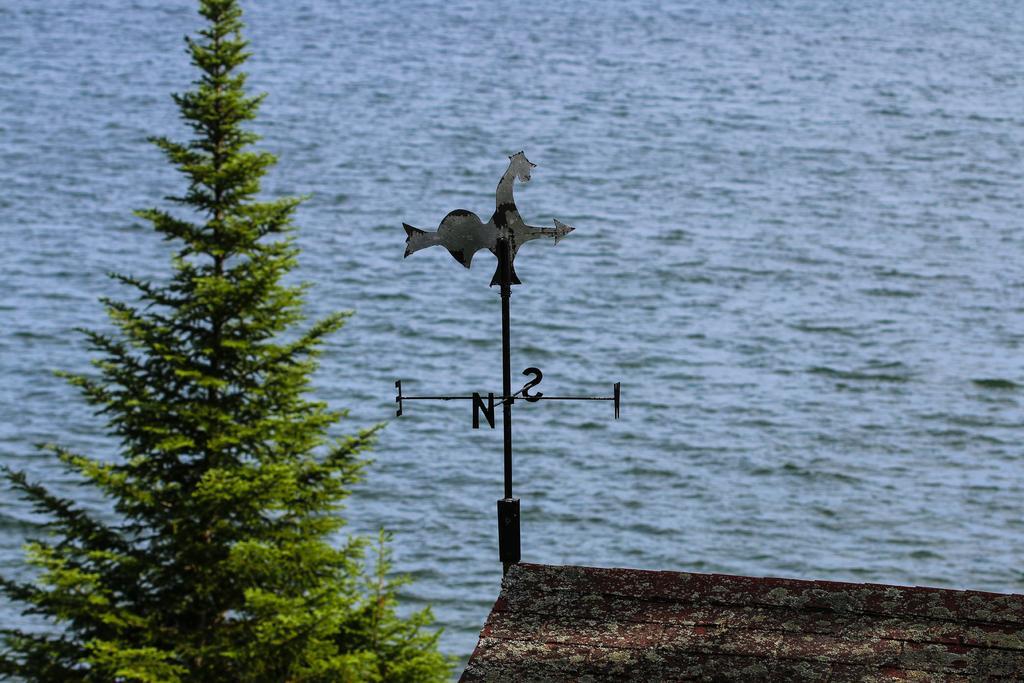Please provide a concise description of this image. In the center of the image we can see a wind vane. On the left side of the image we can see a tree. At the bottom of the image we can see the wall. In the background of the image we can see the water. 